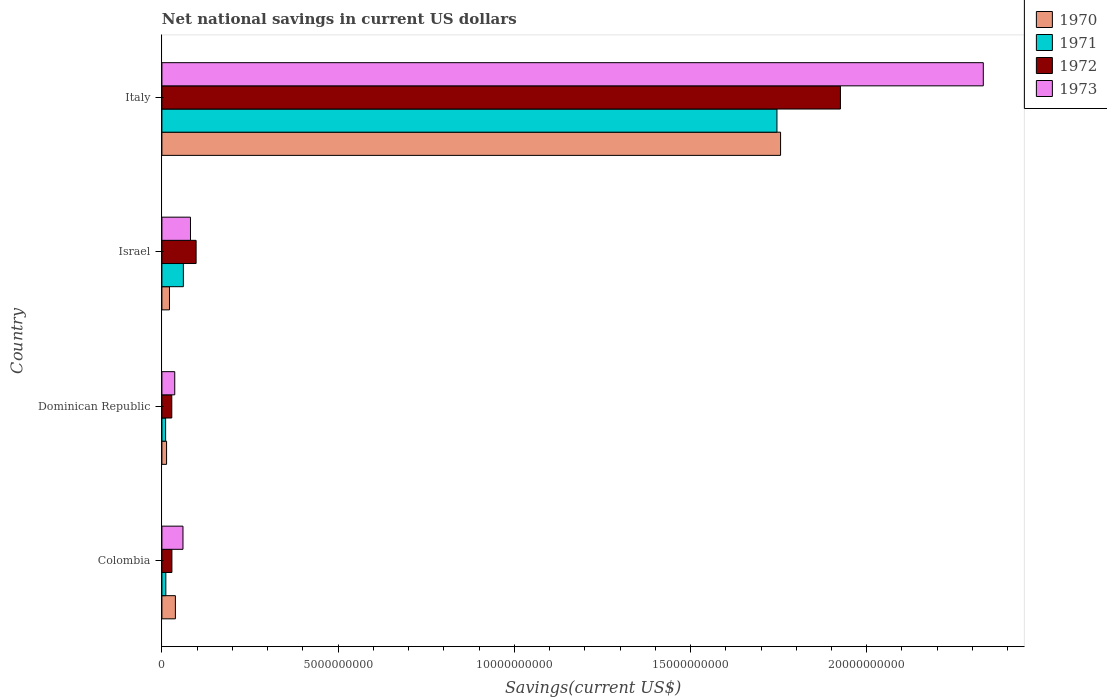How many groups of bars are there?
Keep it short and to the point. 4. How many bars are there on the 3rd tick from the bottom?
Your answer should be very brief. 4. In how many cases, is the number of bars for a given country not equal to the number of legend labels?
Offer a terse response. 0. What is the net national savings in 1973 in Dominican Republic?
Offer a very short reply. 3.65e+08. Across all countries, what is the maximum net national savings in 1970?
Make the answer very short. 1.76e+1. Across all countries, what is the minimum net national savings in 1970?
Ensure brevity in your answer.  1.33e+08. In which country was the net national savings in 1972 minimum?
Keep it short and to the point. Dominican Republic. What is the total net national savings in 1970 in the graph?
Your response must be concise. 1.83e+1. What is the difference between the net national savings in 1971 in Dominican Republic and that in Israel?
Ensure brevity in your answer.  -5.03e+08. What is the difference between the net national savings in 1972 in Italy and the net national savings in 1970 in Israel?
Offer a very short reply. 1.90e+1. What is the average net national savings in 1970 per country?
Give a very brief answer. 4.57e+09. What is the difference between the net national savings in 1972 and net national savings in 1971 in Colombia?
Your response must be concise. 1.73e+08. What is the ratio of the net national savings in 1972 in Israel to that in Italy?
Your response must be concise. 0.05. Is the net national savings in 1973 in Colombia less than that in Italy?
Your answer should be very brief. Yes. Is the difference between the net national savings in 1972 in Israel and Italy greater than the difference between the net national savings in 1971 in Israel and Italy?
Offer a terse response. No. What is the difference between the highest and the second highest net national savings in 1973?
Keep it short and to the point. 2.25e+1. What is the difference between the highest and the lowest net national savings in 1973?
Provide a succinct answer. 2.29e+1. In how many countries, is the net national savings in 1972 greater than the average net national savings in 1972 taken over all countries?
Provide a short and direct response. 1. Is the sum of the net national savings in 1970 in Colombia and Israel greater than the maximum net national savings in 1972 across all countries?
Ensure brevity in your answer.  No. What does the 4th bar from the bottom in Colombia represents?
Keep it short and to the point. 1973. Are all the bars in the graph horizontal?
Your response must be concise. Yes. How many countries are there in the graph?
Your response must be concise. 4. What is the difference between two consecutive major ticks on the X-axis?
Give a very brief answer. 5.00e+09. Are the values on the major ticks of X-axis written in scientific E-notation?
Your answer should be very brief. No. Does the graph contain grids?
Ensure brevity in your answer.  No. How are the legend labels stacked?
Provide a succinct answer. Vertical. What is the title of the graph?
Make the answer very short. Net national savings in current US dollars. Does "1984" appear as one of the legend labels in the graph?
Provide a short and direct response. No. What is the label or title of the X-axis?
Your answer should be compact. Savings(current US$). What is the Savings(current US$) in 1970 in Colombia?
Keep it short and to the point. 3.83e+08. What is the Savings(current US$) of 1971 in Colombia?
Your answer should be compact. 1.11e+08. What is the Savings(current US$) of 1972 in Colombia?
Your answer should be very brief. 2.84e+08. What is the Savings(current US$) in 1973 in Colombia?
Provide a short and direct response. 5.98e+08. What is the Savings(current US$) of 1970 in Dominican Republic?
Your answer should be compact. 1.33e+08. What is the Savings(current US$) in 1971 in Dominican Republic?
Ensure brevity in your answer.  1.05e+08. What is the Savings(current US$) of 1972 in Dominican Republic?
Provide a short and direct response. 2.80e+08. What is the Savings(current US$) of 1973 in Dominican Republic?
Keep it short and to the point. 3.65e+08. What is the Savings(current US$) in 1970 in Israel?
Ensure brevity in your answer.  2.15e+08. What is the Savings(current US$) of 1971 in Israel?
Offer a very short reply. 6.09e+08. What is the Savings(current US$) in 1972 in Israel?
Your response must be concise. 9.71e+08. What is the Savings(current US$) of 1973 in Israel?
Offer a very short reply. 8.11e+08. What is the Savings(current US$) in 1970 in Italy?
Make the answer very short. 1.76e+1. What is the Savings(current US$) in 1971 in Italy?
Provide a short and direct response. 1.75e+1. What is the Savings(current US$) of 1972 in Italy?
Keep it short and to the point. 1.93e+1. What is the Savings(current US$) of 1973 in Italy?
Your response must be concise. 2.33e+1. Across all countries, what is the maximum Savings(current US$) in 1970?
Ensure brevity in your answer.  1.76e+1. Across all countries, what is the maximum Savings(current US$) in 1971?
Ensure brevity in your answer.  1.75e+1. Across all countries, what is the maximum Savings(current US$) of 1972?
Offer a very short reply. 1.93e+1. Across all countries, what is the maximum Savings(current US$) of 1973?
Provide a succinct answer. 2.33e+1. Across all countries, what is the minimum Savings(current US$) of 1970?
Your answer should be very brief. 1.33e+08. Across all countries, what is the minimum Savings(current US$) of 1971?
Offer a terse response. 1.05e+08. Across all countries, what is the minimum Savings(current US$) in 1972?
Your response must be concise. 2.80e+08. Across all countries, what is the minimum Savings(current US$) of 1973?
Make the answer very short. 3.65e+08. What is the total Savings(current US$) of 1970 in the graph?
Provide a succinct answer. 1.83e+1. What is the total Savings(current US$) in 1971 in the graph?
Give a very brief answer. 1.83e+1. What is the total Savings(current US$) in 1972 in the graph?
Give a very brief answer. 2.08e+1. What is the total Savings(current US$) in 1973 in the graph?
Provide a succinct answer. 2.51e+1. What is the difference between the Savings(current US$) in 1970 in Colombia and that in Dominican Republic?
Offer a terse response. 2.50e+08. What is the difference between the Savings(current US$) in 1971 in Colombia and that in Dominican Republic?
Ensure brevity in your answer.  6.03e+06. What is the difference between the Savings(current US$) in 1972 in Colombia and that in Dominican Republic?
Ensure brevity in your answer.  3.48e+06. What is the difference between the Savings(current US$) of 1973 in Colombia and that in Dominican Republic?
Provide a short and direct response. 2.34e+08. What is the difference between the Savings(current US$) of 1970 in Colombia and that in Israel?
Your response must be concise. 1.68e+08. What is the difference between the Savings(current US$) of 1971 in Colombia and that in Israel?
Ensure brevity in your answer.  -4.97e+08. What is the difference between the Savings(current US$) of 1972 in Colombia and that in Israel?
Keep it short and to the point. -6.87e+08. What is the difference between the Savings(current US$) of 1973 in Colombia and that in Israel?
Offer a terse response. -2.12e+08. What is the difference between the Savings(current US$) in 1970 in Colombia and that in Italy?
Your answer should be very brief. -1.72e+1. What is the difference between the Savings(current US$) in 1971 in Colombia and that in Italy?
Offer a very short reply. -1.73e+1. What is the difference between the Savings(current US$) in 1972 in Colombia and that in Italy?
Your response must be concise. -1.90e+1. What is the difference between the Savings(current US$) in 1973 in Colombia and that in Italy?
Provide a succinct answer. -2.27e+1. What is the difference between the Savings(current US$) in 1970 in Dominican Republic and that in Israel?
Your answer should be very brief. -8.19e+07. What is the difference between the Savings(current US$) of 1971 in Dominican Republic and that in Israel?
Keep it short and to the point. -5.03e+08. What is the difference between the Savings(current US$) of 1972 in Dominican Republic and that in Israel?
Your response must be concise. -6.90e+08. What is the difference between the Savings(current US$) of 1973 in Dominican Republic and that in Israel?
Give a very brief answer. -4.46e+08. What is the difference between the Savings(current US$) of 1970 in Dominican Republic and that in Italy?
Your answer should be very brief. -1.74e+1. What is the difference between the Savings(current US$) of 1971 in Dominican Republic and that in Italy?
Give a very brief answer. -1.73e+1. What is the difference between the Savings(current US$) of 1972 in Dominican Republic and that in Italy?
Make the answer very short. -1.90e+1. What is the difference between the Savings(current US$) of 1973 in Dominican Republic and that in Italy?
Ensure brevity in your answer.  -2.29e+1. What is the difference between the Savings(current US$) of 1970 in Israel and that in Italy?
Offer a terse response. -1.73e+1. What is the difference between the Savings(current US$) of 1971 in Israel and that in Italy?
Your answer should be compact. -1.68e+1. What is the difference between the Savings(current US$) in 1972 in Israel and that in Italy?
Your answer should be very brief. -1.83e+1. What is the difference between the Savings(current US$) in 1973 in Israel and that in Italy?
Offer a terse response. -2.25e+1. What is the difference between the Savings(current US$) in 1970 in Colombia and the Savings(current US$) in 1971 in Dominican Republic?
Make the answer very short. 2.77e+08. What is the difference between the Savings(current US$) in 1970 in Colombia and the Savings(current US$) in 1972 in Dominican Republic?
Keep it short and to the point. 1.02e+08. What is the difference between the Savings(current US$) of 1970 in Colombia and the Savings(current US$) of 1973 in Dominican Republic?
Provide a short and direct response. 1.82e+07. What is the difference between the Savings(current US$) in 1971 in Colombia and the Savings(current US$) in 1972 in Dominican Republic?
Make the answer very short. -1.69e+08. What is the difference between the Savings(current US$) of 1971 in Colombia and the Savings(current US$) of 1973 in Dominican Republic?
Your response must be concise. -2.53e+08. What is the difference between the Savings(current US$) of 1972 in Colombia and the Savings(current US$) of 1973 in Dominican Republic?
Make the answer very short. -8.05e+07. What is the difference between the Savings(current US$) of 1970 in Colombia and the Savings(current US$) of 1971 in Israel?
Offer a terse response. -2.26e+08. What is the difference between the Savings(current US$) of 1970 in Colombia and the Savings(current US$) of 1972 in Israel?
Offer a very short reply. -5.88e+08. What is the difference between the Savings(current US$) in 1970 in Colombia and the Savings(current US$) in 1973 in Israel?
Make the answer very short. -4.28e+08. What is the difference between the Savings(current US$) of 1971 in Colombia and the Savings(current US$) of 1972 in Israel?
Provide a short and direct response. -8.59e+08. What is the difference between the Savings(current US$) in 1971 in Colombia and the Savings(current US$) in 1973 in Israel?
Offer a terse response. -6.99e+08. What is the difference between the Savings(current US$) in 1972 in Colombia and the Savings(current US$) in 1973 in Israel?
Keep it short and to the point. -5.27e+08. What is the difference between the Savings(current US$) in 1970 in Colombia and the Savings(current US$) in 1971 in Italy?
Give a very brief answer. -1.71e+1. What is the difference between the Savings(current US$) in 1970 in Colombia and the Savings(current US$) in 1972 in Italy?
Offer a terse response. -1.89e+1. What is the difference between the Savings(current US$) in 1970 in Colombia and the Savings(current US$) in 1973 in Italy?
Your response must be concise. -2.29e+1. What is the difference between the Savings(current US$) of 1971 in Colombia and the Savings(current US$) of 1972 in Italy?
Your answer should be compact. -1.91e+1. What is the difference between the Savings(current US$) of 1971 in Colombia and the Savings(current US$) of 1973 in Italy?
Offer a terse response. -2.32e+1. What is the difference between the Savings(current US$) of 1972 in Colombia and the Savings(current US$) of 1973 in Italy?
Your response must be concise. -2.30e+1. What is the difference between the Savings(current US$) of 1970 in Dominican Republic and the Savings(current US$) of 1971 in Israel?
Your answer should be very brief. -4.76e+08. What is the difference between the Savings(current US$) of 1970 in Dominican Republic and the Savings(current US$) of 1972 in Israel?
Offer a terse response. -8.38e+08. What is the difference between the Savings(current US$) in 1970 in Dominican Republic and the Savings(current US$) in 1973 in Israel?
Offer a terse response. -6.78e+08. What is the difference between the Savings(current US$) of 1971 in Dominican Republic and the Savings(current US$) of 1972 in Israel?
Give a very brief answer. -8.65e+08. What is the difference between the Savings(current US$) of 1971 in Dominican Republic and the Savings(current US$) of 1973 in Israel?
Give a very brief answer. -7.05e+08. What is the difference between the Savings(current US$) of 1972 in Dominican Republic and the Savings(current US$) of 1973 in Israel?
Give a very brief answer. -5.30e+08. What is the difference between the Savings(current US$) of 1970 in Dominican Republic and the Savings(current US$) of 1971 in Italy?
Ensure brevity in your answer.  -1.73e+1. What is the difference between the Savings(current US$) of 1970 in Dominican Republic and the Savings(current US$) of 1972 in Italy?
Ensure brevity in your answer.  -1.91e+1. What is the difference between the Savings(current US$) in 1970 in Dominican Republic and the Savings(current US$) in 1973 in Italy?
Your answer should be very brief. -2.32e+1. What is the difference between the Savings(current US$) in 1971 in Dominican Republic and the Savings(current US$) in 1972 in Italy?
Give a very brief answer. -1.91e+1. What is the difference between the Savings(current US$) of 1971 in Dominican Republic and the Savings(current US$) of 1973 in Italy?
Provide a short and direct response. -2.32e+1. What is the difference between the Savings(current US$) in 1972 in Dominican Republic and the Savings(current US$) in 1973 in Italy?
Keep it short and to the point. -2.30e+1. What is the difference between the Savings(current US$) in 1970 in Israel and the Savings(current US$) in 1971 in Italy?
Give a very brief answer. -1.72e+1. What is the difference between the Savings(current US$) of 1970 in Israel and the Savings(current US$) of 1972 in Italy?
Offer a terse response. -1.90e+1. What is the difference between the Savings(current US$) in 1970 in Israel and the Savings(current US$) in 1973 in Italy?
Keep it short and to the point. -2.31e+1. What is the difference between the Savings(current US$) of 1971 in Israel and the Savings(current US$) of 1972 in Italy?
Provide a succinct answer. -1.86e+1. What is the difference between the Savings(current US$) of 1971 in Israel and the Savings(current US$) of 1973 in Italy?
Your answer should be compact. -2.27e+1. What is the difference between the Savings(current US$) in 1972 in Israel and the Savings(current US$) in 1973 in Italy?
Your answer should be very brief. -2.23e+1. What is the average Savings(current US$) in 1970 per country?
Your answer should be compact. 4.57e+09. What is the average Savings(current US$) in 1971 per country?
Provide a short and direct response. 4.57e+09. What is the average Savings(current US$) of 1972 per country?
Make the answer very short. 5.20e+09. What is the average Savings(current US$) of 1973 per country?
Your answer should be compact. 6.27e+09. What is the difference between the Savings(current US$) in 1970 and Savings(current US$) in 1971 in Colombia?
Your answer should be very brief. 2.71e+08. What is the difference between the Savings(current US$) of 1970 and Savings(current US$) of 1972 in Colombia?
Give a very brief answer. 9.87e+07. What is the difference between the Savings(current US$) in 1970 and Savings(current US$) in 1973 in Colombia?
Your answer should be very brief. -2.16e+08. What is the difference between the Savings(current US$) in 1971 and Savings(current US$) in 1972 in Colombia?
Give a very brief answer. -1.73e+08. What is the difference between the Savings(current US$) in 1971 and Savings(current US$) in 1973 in Colombia?
Your answer should be compact. -4.87e+08. What is the difference between the Savings(current US$) of 1972 and Savings(current US$) of 1973 in Colombia?
Your response must be concise. -3.14e+08. What is the difference between the Savings(current US$) in 1970 and Savings(current US$) in 1971 in Dominican Republic?
Your answer should be compact. 2.74e+07. What is the difference between the Savings(current US$) in 1970 and Savings(current US$) in 1972 in Dominican Republic?
Your answer should be compact. -1.48e+08. What is the difference between the Savings(current US$) in 1970 and Savings(current US$) in 1973 in Dominican Republic?
Ensure brevity in your answer.  -2.32e+08. What is the difference between the Savings(current US$) of 1971 and Savings(current US$) of 1972 in Dominican Republic?
Give a very brief answer. -1.75e+08. What is the difference between the Savings(current US$) of 1971 and Savings(current US$) of 1973 in Dominican Republic?
Provide a succinct answer. -2.59e+08. What is the difference between the Savings(current US$) of 1972 and Savings(current US$) of 1973 in Dominican Republic?
Keep it short and to the point. -8.40e+07. What is the difference between the Savings(current US$) in 1970 and Savings(current US$) in 1971 in Israel?
Offer a very short reply. -3.94e+08. What is the difference between the Savings(current US$) of 1970 and Savings(current US$) of 1972 in Israel?
Your answer should be very brief. -7.56e+08. What is the difference between the Savings(current US$) of 1970 and Savings(current US$) of 1973 in Israel?
Give a very brief answer. -5.96e+08. What is the difference between the Savings(current US$) in 1971 and Savings(current US$) in 1972 in Israel?
Provide a short and direct response. -3.62e+08. What is the difference between the Savings(current US$) of 1971 and Savings(current US$) of 1973 in Israel?
Your response must be concise. -2.02e+08. What is the difference between the Savings(current US$) in 1972 and Savings(current US$) in 1973 in Israel?
Give a very brief answer. 1.60e+08. What is the difference between the Savings(current US$) in 1970 and Savings(current US$) in 1971 in Italy?
Provide a succinct answer. 1.03e+08. What is the difference between the Savings(current US$) of 1970 and Savings(current US$) of 1972 in Italy?
Provide a short and direct response. -1.70e+09. What is the difference between the Savings(current US$) in 1970 and Savings(current US$) in 1973 in Italy?
Your response must be concise. -5.75e+09. What is the difference between the Savings(current US$) in 1971 and Savings(current US$) in 1972 in Italy?
Your answer should be compact. -1.80e+09. What is the difference between the Savings(current US$) of 1971 and Savings(current US$) of 1973 in Italy?
Give a very brief answer. -5.86e+09. What is the difference between the Savings(current US$) in 1972 and Savings(current US$) in 1973 in Italy?
Keep it short and to the point. -4.05e+09. What is the ratio of the Savings(current US$) in 1970 in Colombia to that in Dominican Republic?
Ensure brevity in your answer.  2.88. What is the ratio of the Savings(current US$) of 1971 in Colombia to that in Dominican Republic?
Keep it short and to the point. 1.06. What is the ratio of the Savings(current US$) in 1972 in Colombia to that in Dominican Republic?
Your response must be concise. 1.01. What is the ratio of the Savings(current US$) of 1973 in Colombia to that in Dominican Republic?
Your answer should be very brief. 1.64. What is the ratio of the Savings(current US$) in 1970 in Colombia to that in Israel?
Provide a succinct answer. 1.78. What is the ratio of the Savings(current US$) in 1971 in Colombia to that in Israel?
Your response must be concise. 0.18. What is the ratio of the Savings(current US$) of 1972 in Colombia to that in Israel?
Give a very brief answer. 0.29. What is the ratio of the Savings(current US$) in 1973 in Colombia to that in Israel?
Your answer should be very brief. 0.74. What is the ratio of the Savings(current US$) in 1970 in Colombia to that in Italy?
Offer a very short reply. 0.02. What is the ratio of the Savings(current US$) of 1971 in Colombia to that in Italy?
Offer a terse response. 0.01. What is the ratio of the Savings(current US$) in 1972 in Colombia to that in Italy?
Ensure brevity in your answer.  0.01. What is the ratio of the Savings(current US$) in 1973 in Colombia to that in Italy?
Give a very brief answer. 0.03. What is the ratio of the Savings(current US$) in 1970 in Dominican Republic to that in Israel?
Provide a succinct answer. 0.62. What is the ratio of the Savings(current US$) of 1971 in Dominican Republic to that in Israel?
Keep it short and to the point. 0.17. What is the ratio of the Savings(current US$) in 1972 in Dominican Republic to that in Israel?
Make the answer very short. 0.29. What is the ratio of the Savings(current US$) in 1973 in Dominican Republic to that in Israel?
Ensure brevity in your answer.  0.45. What is the ratio of the Savings(current US$) in 1970 in Dominican Republic to that in Italy?
Provide a succinct answer. 0.01. What is the ratio of the Savings(current US$) in 1971 in Dominican Republic to that in Italy?
Offer a very short reply. 0.01. What is the ratio of the Savings(current US$) in 1972 in Dominican Republic to that in Italy?
Give a very brief answer. 0.01. What is the ratio of the Savings(current US$) in 1973 in Dominican Republic to that in Italy?
Offer a very short reply. 0.02. What is the ratio of the Savings(current US$) of 1970 in Israel to that in Italy?
Your answer should be compact. 0.01. What is the ratio of the Savings(current US$) of 1971 in Israel to that in Italy?
Offer a very short reply. 0.03. What is the ratio of the Savings(current US$) of 1972 in Israel to that in Italy?
Provide a succinct answer. 0.05. What is the ratio of the Savings(current US$) of 1973 in Israel to that in Italy?
Keep it short and to the point. 0.03. What is the difference between the highest and the second highest Savings(current US$) in 1970?
Give a very brief answer. 1.72e+1. What is the difference between the highest and the second highest Savings(current US$) of 1971?
Your response must be concise. 1.68e+1. What is the difference between the highest and the second highest Savings(current US$) of 1972?
Keep it short and to the point. 1.83e+1. What is the difference between the highest and the second highest Savings(current US$) of 1973?
Offer a very short reply. 2.25e+1. What is the difference between the highest and the lowest Savings(current US$) of 1970?
Offer a very short reply. 1.74e+1. What is the difference between the highest and the lowest Savings(current US$) of 1971?
Your response must be concise. 1.73e+1. What is the difference between the highest and the lowest Savings(current US$) in 1972?
Make the answer very short. 1.90e+1. What is the difference between the highest and the lowest Savings(current US$) in 1973?
Offer a terse response. 2.29e+1. 